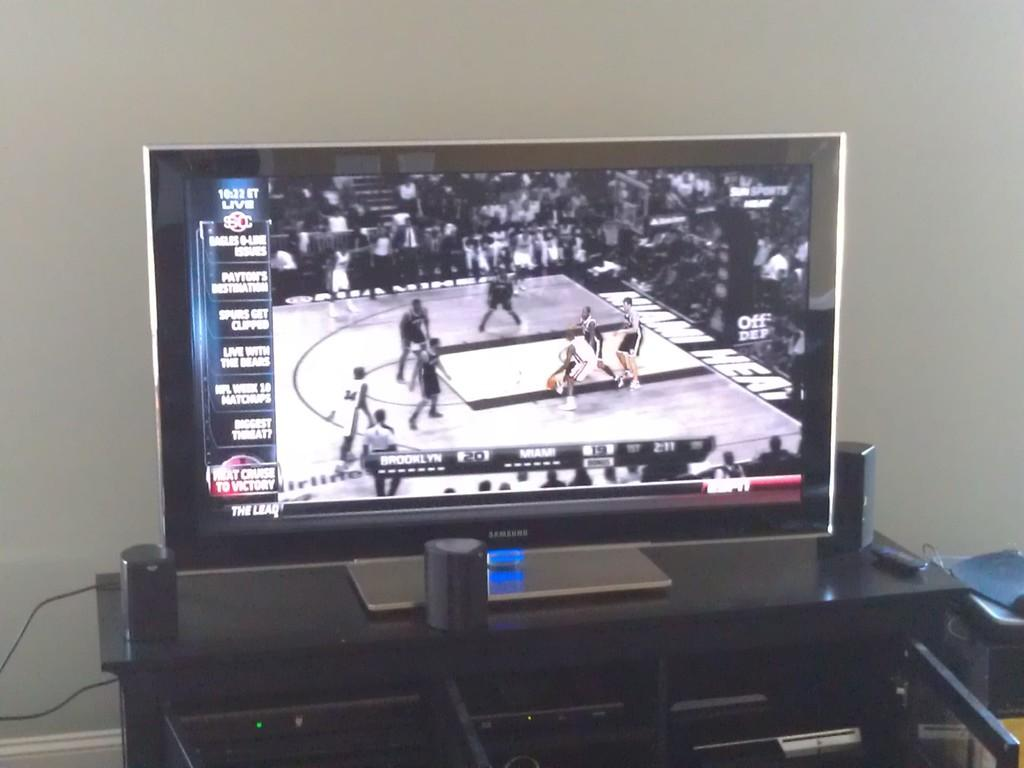Provide a one-sentence caption for the provided image. A basketball game is being watched on a Samsung tv. 